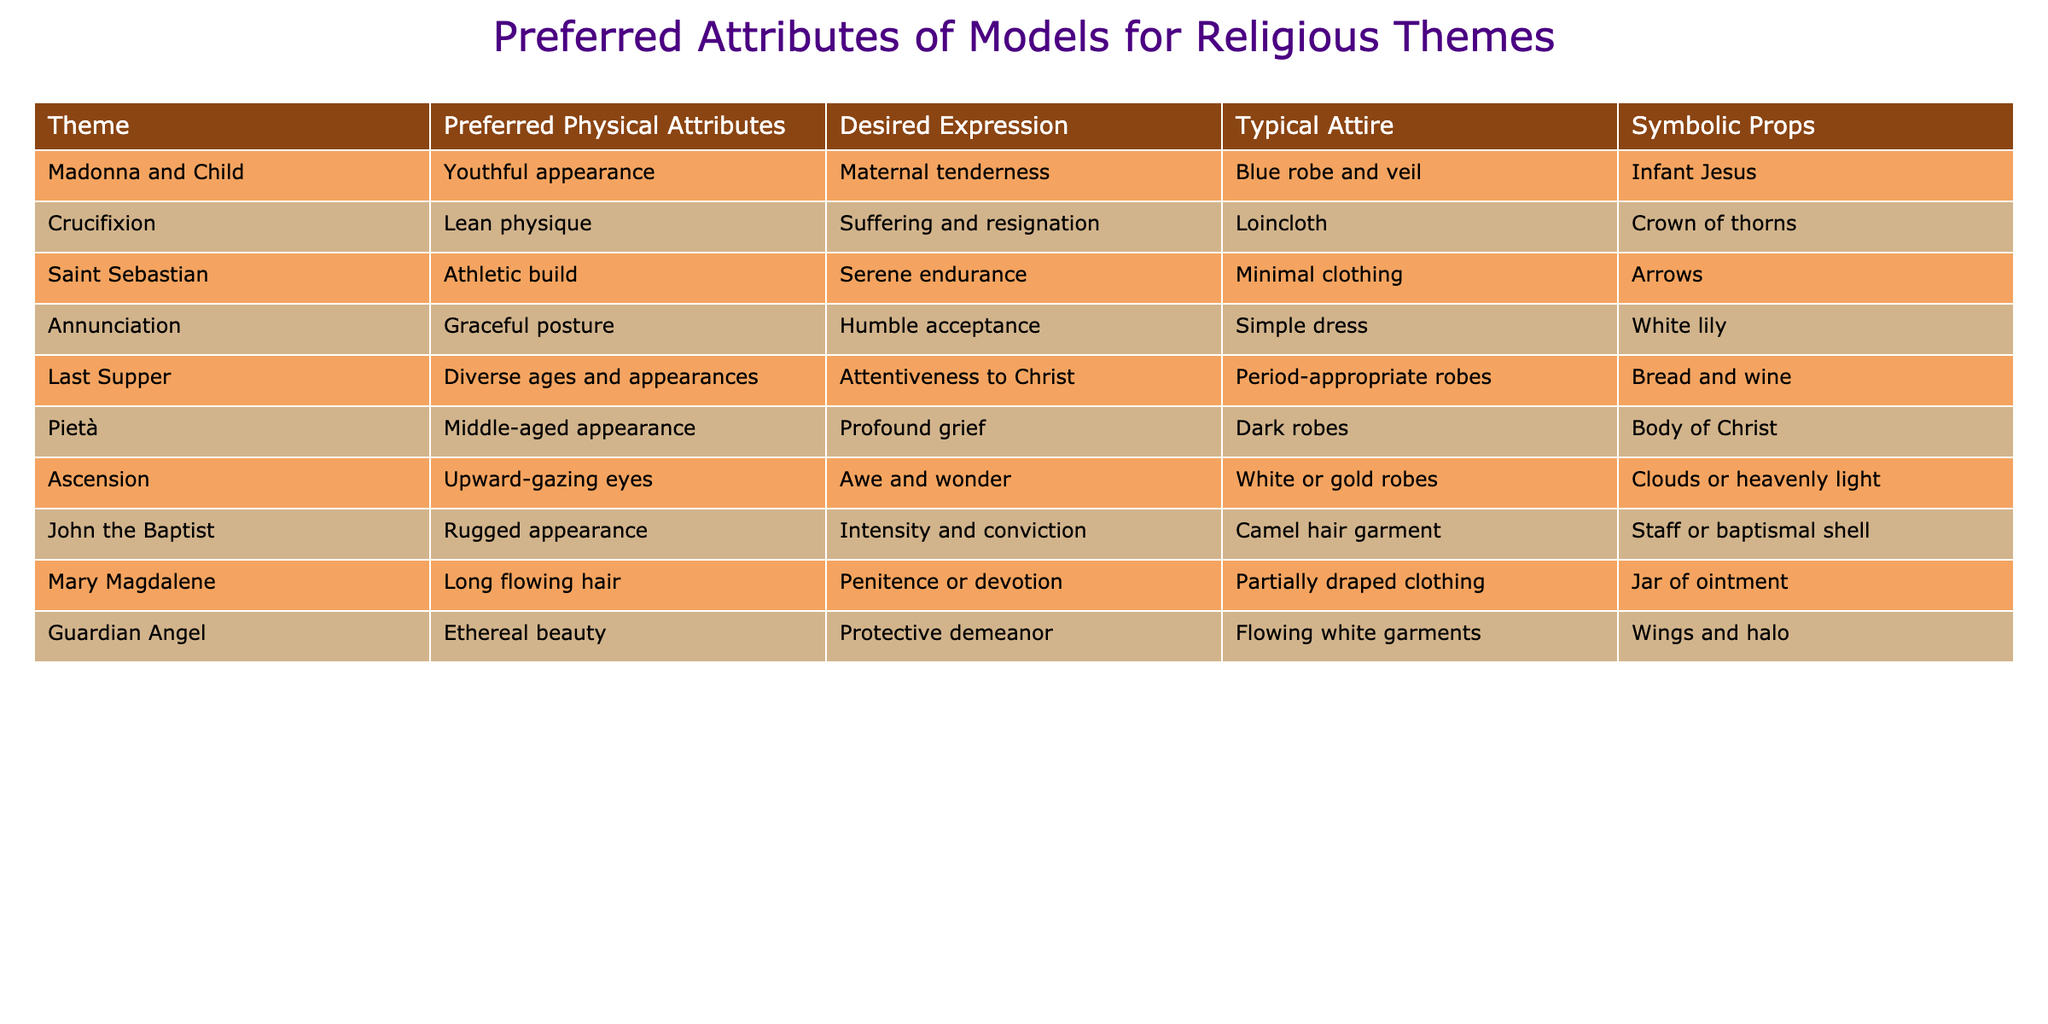What are the preferred physical attributes for the theme of the Pietà? The table lists "Middle-aged appearance" as the preferred physical attribute for the theme of the Pietà.
Answer: Middle-aged appearance Which theme features models with an athletic build? According to the table, the theme of Saint Sebastian features models with an athletic build.
Answer: Saint Sebastian Is it true that the Annunciation requires models to wear blue robes? The table indicates that for the Annunciation, models wear simple dress, not blue robes. Therefore, the statement is false.
Answer: False What expression is desired for the Guardian Angel theme? The table shows that the desired expression for the Guardian Angel theme is "Protective demeanor."
Answer: Protective demeanor How many themes have a typical attire that includes robes? Reviewing the table, the themes with robes are Madonna and Child, Last Supper, Pietà, and the Ascension. This gives us a total of four themes.
Answer: 4 Which two themes share the same symbolic prop of a jar of ointment? The table identifies that only Mary Magdalene has a jar of ointment as a symbolic prop; therefore, there are no two themes that share this prop.
Answer: None What is the desired expression for the theme represented by John the Baptist? The desired expression for John the Baptist, as listed in the table, is "Intensity and conviction."
Answer: Intensity and conviction Which theme has the most diverse representation in terms of ages and appearances? The Last Supper is noted in the table for having a diverse representation in terms of ages and appearances.
Answer: Last Supper If we compare the themes of Crucifixion and Ascension based on their desired expressions, which one embodies a more optimistic sentiment? The Crucifixion expresses "Suffering and resignation," while the Ascension expresses "Awe and wonder," which is more optimistic. Therefore, Ascension embodies a more optimistic sentiment.
Answer: Ascension How does the typical attire of Mary Magdalene differ from that of John the Baptist? Mary Magdalene's typical attire is "Partially draped clothing," while John the Baptist wears a "Camel hair garment"; thus, they differ in style and coverage.
Answer: They differ in style and coverage 